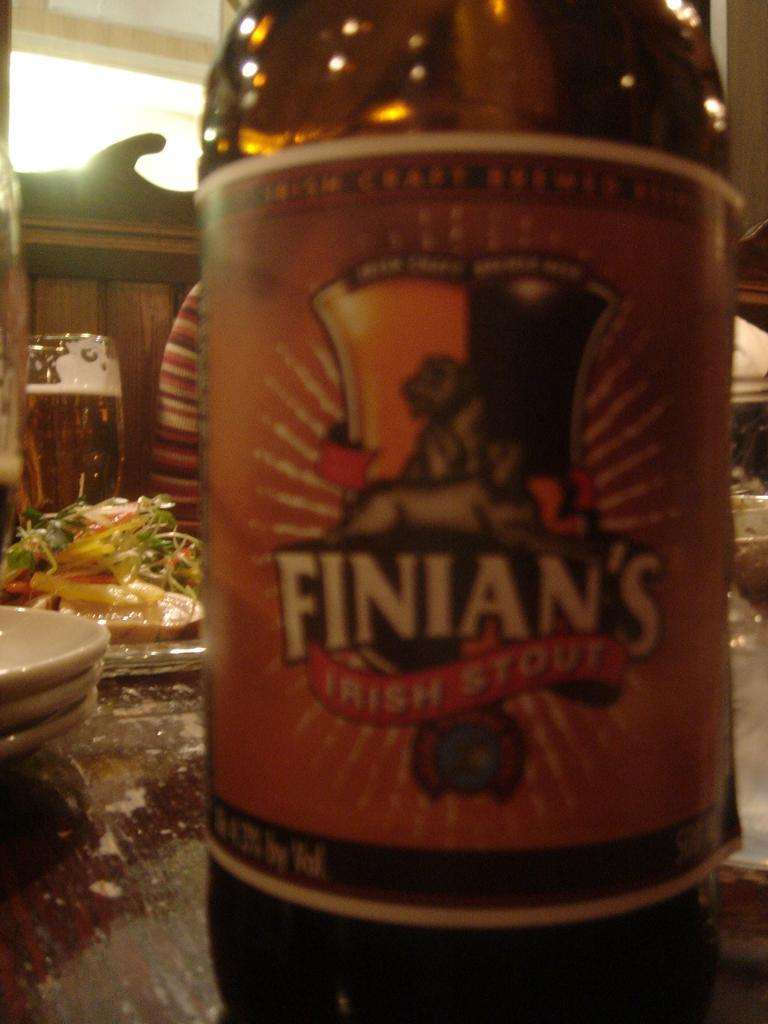<image>
Give a short and clear explanation of the subsequent image. A beverage placed on a table known as Finian's. 